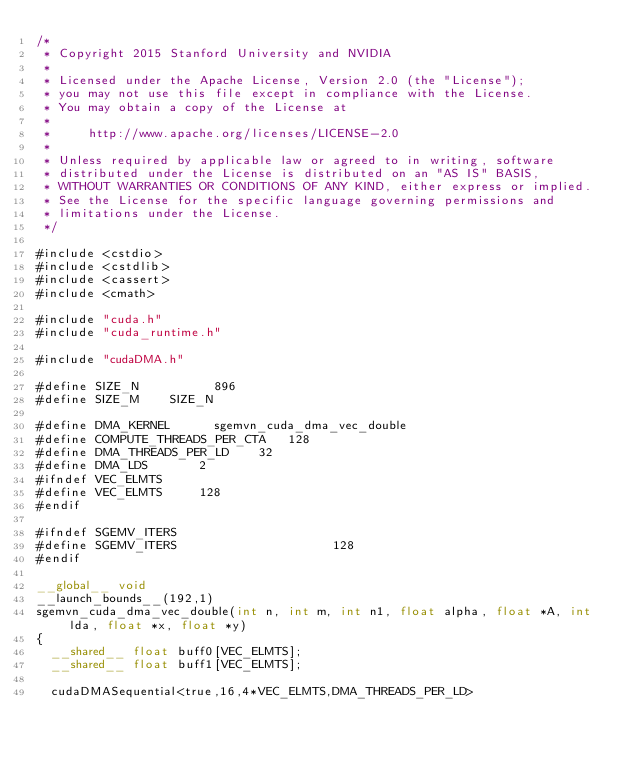Convert code to text. <code><loc_0><loc_0><loc_500><loc_500><_Cuda_>/*
 * Copyright 2015 Stanford University and NVIDIA
 *
 * Licensed under the Apache License, Version 2.0 (the "License");
 * you may not use this file except in compliance with the License.
 * You may obtain a copy of the License at
 *
 *     http://www.apache.org/licenses/LICENSE-2.0
 *
 * Unless required by applicable law or agreed to in writing, software
 * distributed under the License is distributed on an "AS IS" BASIS,
 * WITHOUT WARRANTIES OR CONDITIONS OF ANY KIND, either express or implied.
 * See the License for the specific language governing permissions and
 * limitations under the License.
 */

#include <cstdio>
#include <cstdlib>
#include <cassert>
#include <cmath>

#include "cuda.h"
#include "cuda_runtime.h"

#include "cudaDMA.h"

#define SIZE_N	        896
#define SIZE_M		SIZE_N

#define DMA_KERNEL			sgemvn_cuda_dma_vec_double
#define COMPUTE_THREADS_PER_CTA		128	
#define DMA_THREADS_PER_LD		32	
#define DMA_LDS				2
#ifndef VEC_ELMTS
#define VEC_ELMTS			128
#endif

#ifndef SGEMV_ITERS
#define SGEMV_ITERS                     128
#endif

__global__ void
__launch_bounds__(192,1)
sgemvn_cuda_dma_vec_double(int n, int m, int n1, float alpha, float *A, int lda, float *x, float *y)
{
	__shared__ float buff0[VEC_ELMTS];
	__shared__ float buff1[VEC_ELMTS];

	cudaDMASequential<true,16,4*VEC_ELMTS,DMA_THREADS_PER_LD></code> 